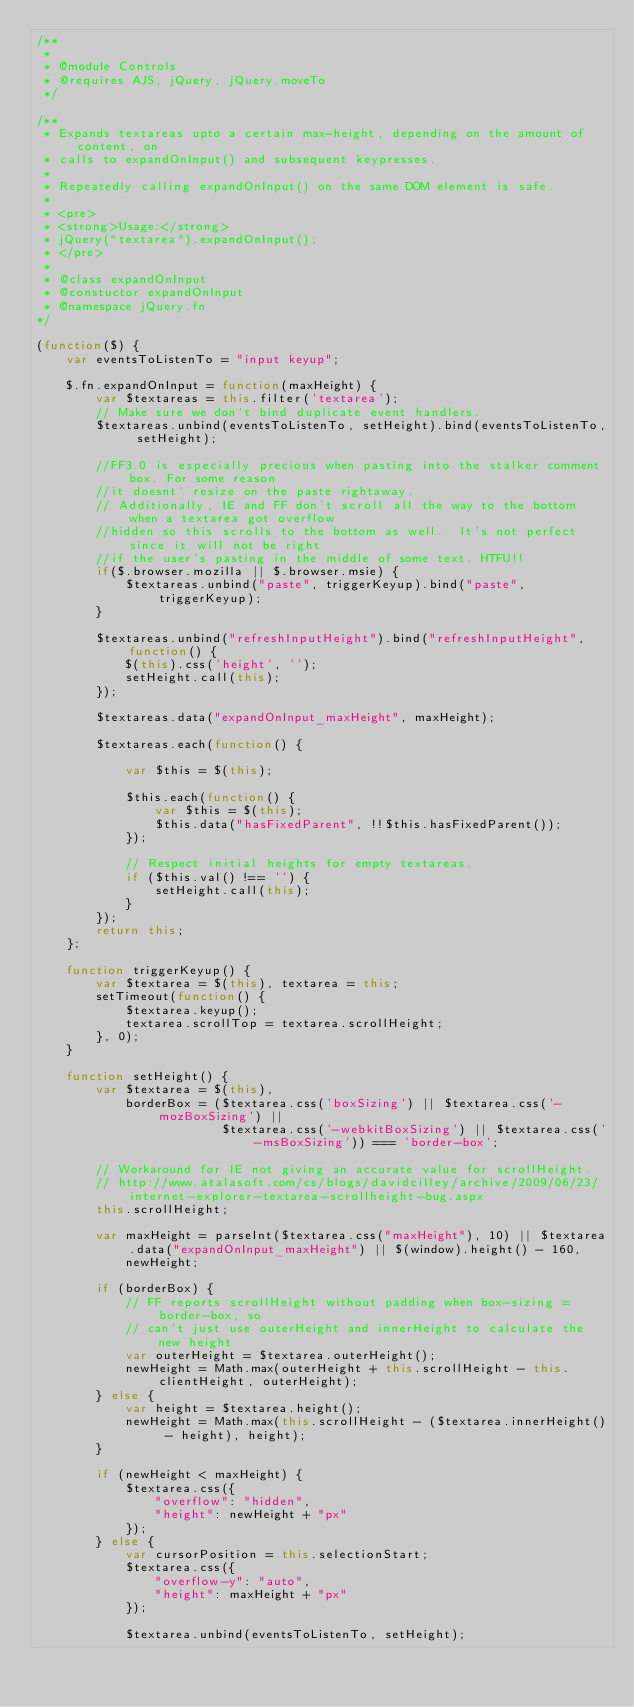<code> <loc_0><loc_0><loc_500><loc_500><_JavaScript_>/**
 *
 * @module Controls
 * @requires AJS, jQuery, jQuery.moveTo
 */

/**
 * Expands textareas upto a certain max-height, depending on the amount of content, on
 * calls to expandOnInput() and subsequent keypresses.
 *
 * Repeatedly calling expandOnInput() on the same DOM element is safe. 
 *
 * <pre>
 * <strong>Usage:</strong>
 * jQuery("textarea").expandOnInput();
 * </pre>
 *
 * @class expandOnInput
 * @constuctor expandOnInput
 * @namespace jQuery.fn
*/

(function($) {
    var eventsToListenTo = "input keyup";

    $.fn.expandOnInput = function(maxHeight) {
        var $textareas = this.filter('textarea');
        // Make sure we don't bind duplicate event handlers.
        $textareas.unbind(eventsToListenTo, setHeight).bind(eventsToListenTo, setHeight);

        //FF3.0 is especially precious when pasting into the stalker comment box. For some reason
        //it doesnt' resize on the paste rightaway.
        // Additionally, IE and FF don't scroll all the way to the bottom when a textarea got overflow
        //hidden so this scrolls to the bottom as well.  It's not perfect since it will not be right
        //if the user's pasting in the middle of some text. HTFU!!
        if($.browser.mozilla || $.browser.msie) {
            $textareas.unbind("paste", triggerKeyup).bind("paste", triggerKeyup);
        }

        $textareas.unbind("refreshInputHeight").bind("refreshInputHeight", function() {
            $(this).css('height', '');
            setHeight.call(this);
        });

        $textareas.data("expandOnInput_maxHeight", maxHeight);

        $textareas.each(function() {

            var $this = $(this);

            $this.each(function() {
                var $this = $(this);
                $this.data("hasFixedParent", !!$this.hasFixedParent());
            });

            // Respect initial heights for empty textareas.
            if ($this.val() !== '') {
                setHeight.call(this);
            }
        });
        return this;
    };

    function triggerKeyup() {
        var $textarea = $(this), textarea = this;
        setTimeout(function() {
            $textarea.keyup();
            textarea.scrollTop = textarea.scrollHeight;
        }, 0);
    }

    function setHeight() {
        var $textarea = $(this),
            borderBox = ($textarea.css('boxSizing') || $textarea.css('-mozBoxSizing') ||
                         $textarea.css('-webkitBoxSizing') || $textarea.css('-msBoxSizing')) === 'border-box';

        // Workaround for IE not giving an accurate value for scrollHeight.
        // http://www.atalasoft.com/cs/blogs/davidcilley/archive/2009/06/23/internet-explorer-textarea-scrollheight-bug.aspx
        this.scrollHeight;

        var maxHeight = parseInt($textarea.css("maxHeight"), 10) || $textarea.data("expandOnInput_maxHeight") || $(window).height() - 160,
            newHeight;

        if (borderBox) {
            // FF reports scrollHeight without padding when box-sizing = border-box, so
            // can't just use outerHeight and innerHeight to calculate the new height
            var outerHeight = $textarea.outerHeight();
            newHeight = Math.max(outerHeight + this.scrollHeight - this.clientHeight, outerHeight);
        } else {
            var height = $textarea.height();
            newHeight = Math.max(this.scrollHeight - ($textarea.innerHeight() - height), height);
        }

        if (newHeight < maxHeight) {
            $textarea.css({
                "overflow": "hidden",
                "height": newHeight + "px"
            });
        } else {
            var cursorPosition = this.selectionStart;
            $textarea.css({
                "overflow-y": "auto",
                "height": maxHeight + "px"
            });

            $textarea.unbind(eventsToListenTo, setHeight);</code> 